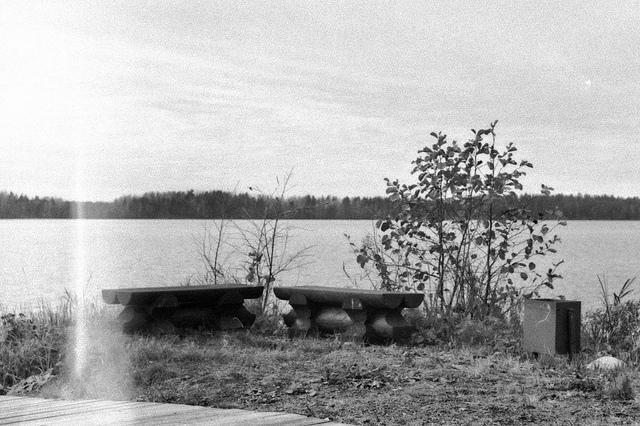How many benches are there?
Give a very brief answer. 2. How many benches are visible?
Give a very brief answer. 2. How many cars are in the picture?
Give a very brief answer. 0. 